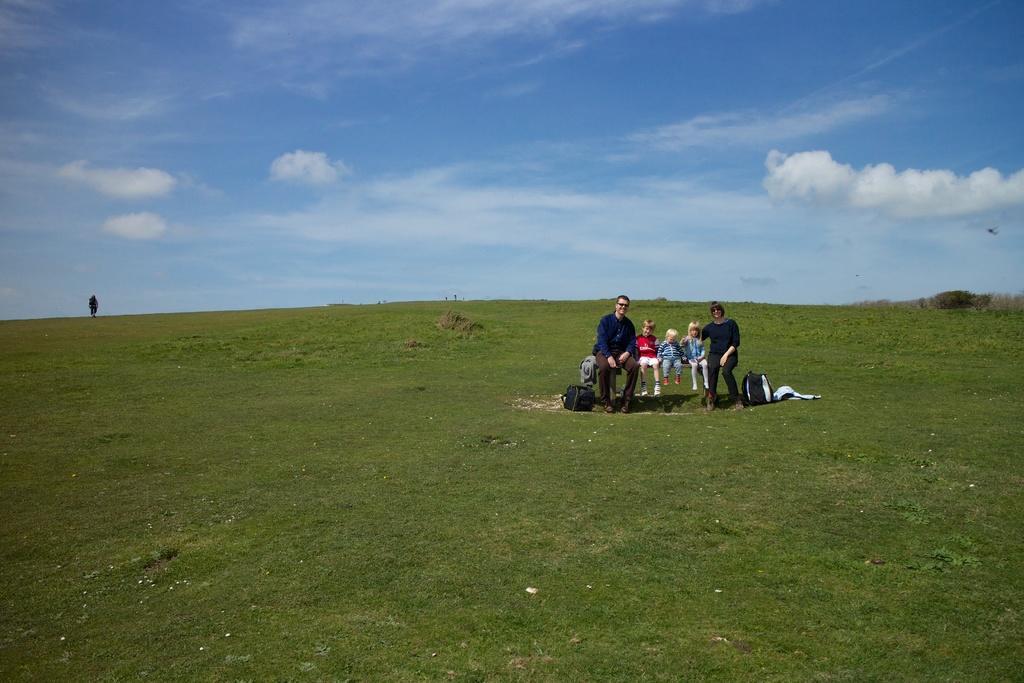In one or two sentences, can you explain what this image depicts? In this picture we can see there are five persons sitting on a bench. On the right side of the image, there are trees. Behind the people, there is grass and the sky. 